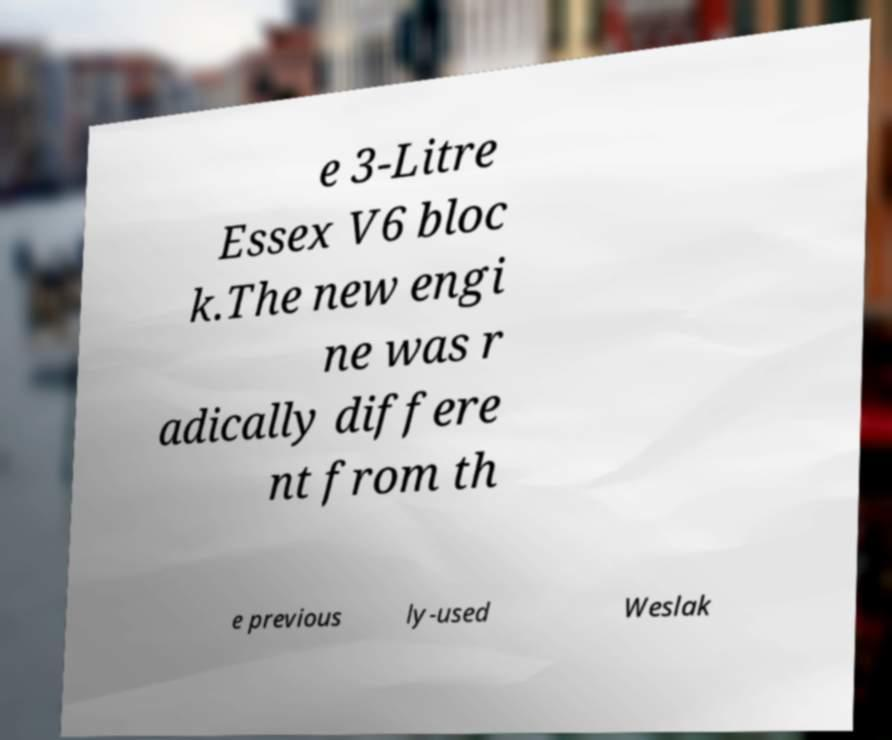What messages or text are displayed in this image? I need them in a readable, typed format. e 3-Litre Essex V6 bloc k.The new engi ne was r adically differe nt from th e previous ly-used Weslak 